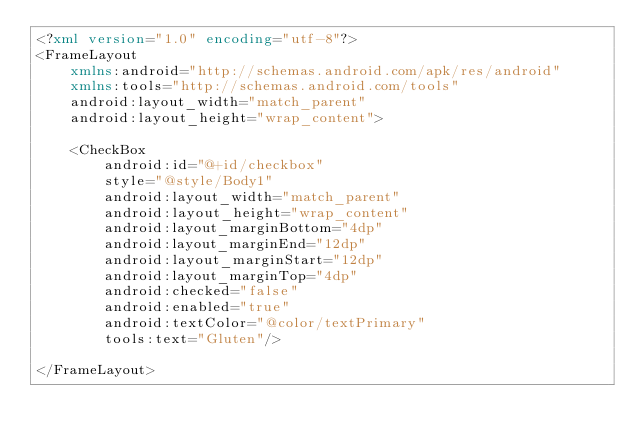Convert code to text. <code><loc_0><loc_0><loc_500><loc_500><_XML_><?xml version="1.0" encoding="utf-8"?>
<FrameLayout
    xmlns:android="http://schemas.android.com/apk/res/android"
    xmlns:tools="http://schemas.android.com/tools"
    android:layout_width="match_parent"
    android:layout_height="wrap_content">

    <CheckBox
        android:id="@+id/checkbox"
        style="@style/Body1"
        android:layout_width="match_parent"
        android:layout_height="wrap_content"
        android:layout_marginBottom="4dp"
        android:layout_marginEnd="12dp"
        android:layout_marginStart="12dp"
        android:layout_marginTop="4dp"
        android:checked="false"
        android:enabled="true"
        android:textColor="@color/textPrimary"
        tools:text="Gluten"/>

</FrameLayout></code> 